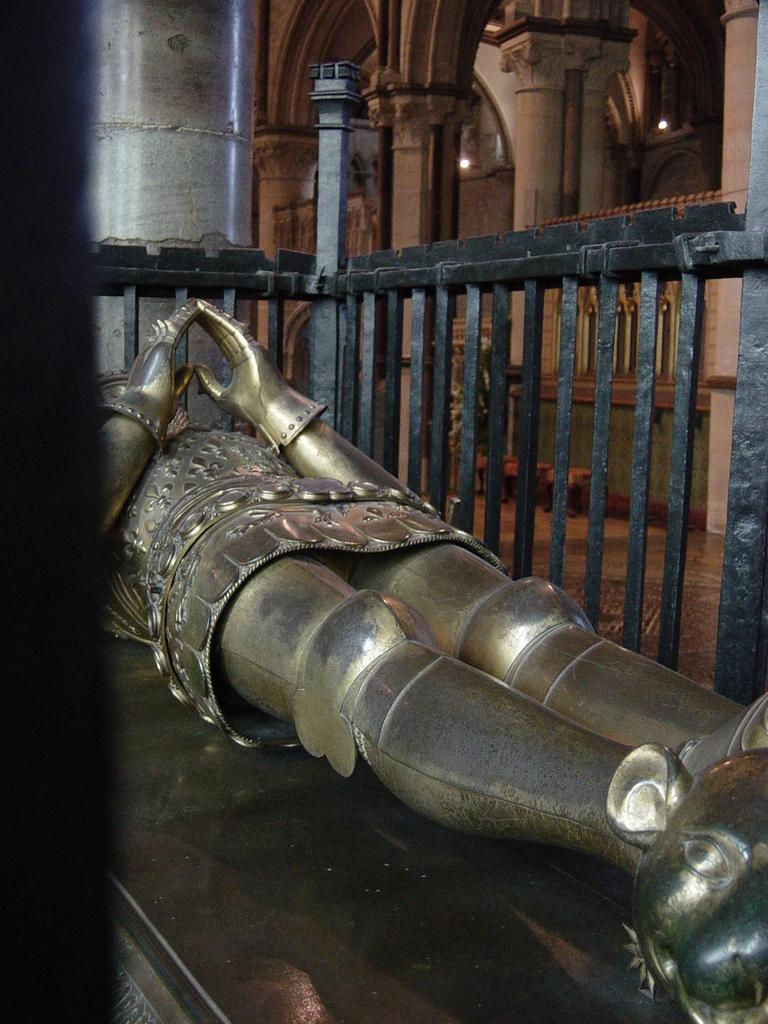What is the main subject in the middle of the image? There is a statue in the middle of the image. What can be seen in the background of the image? There is a fence and pillars in the background of the image. What type of secretary is working behind the pillars in the image? There is no secretary present in the image; it only features a statue, a fence, and pillars. 